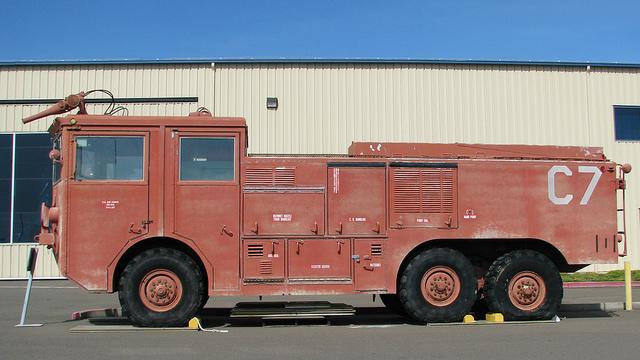What is the letter and number on the truck?
Keep it brief. C7. Could this truck be out-of-service?
Write a very short answer. Yes. Is that a train?
Keep it brief. No. 